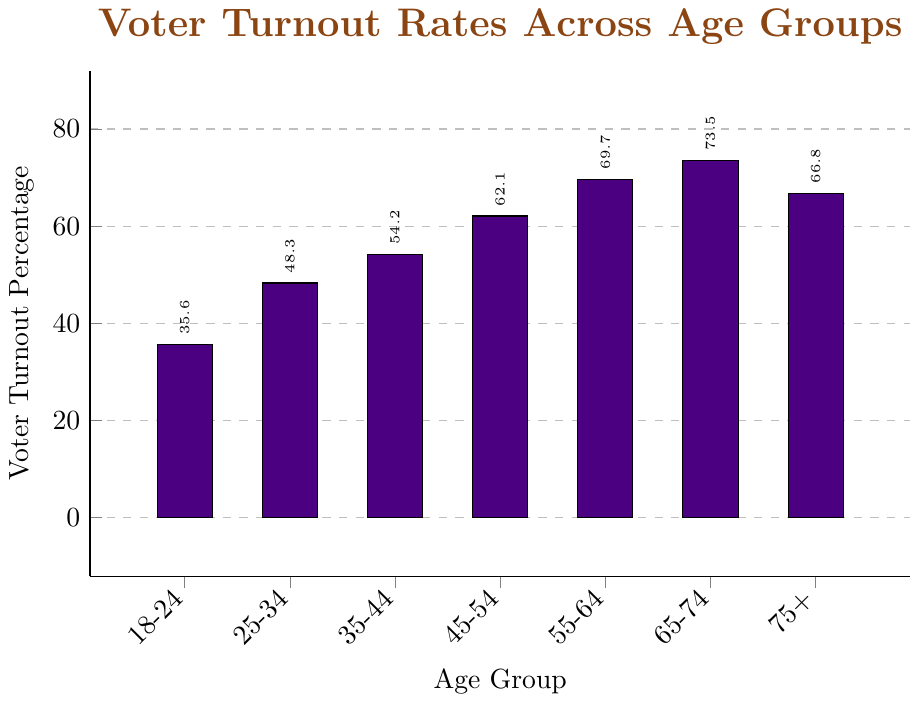What is the voter turnout percentage for the age group 18-24? Locate the bar labeled "18-24" and check the height of the bar, which indicates the voter turnout percentage.
Answer: 35.6% Which age group has the highest voter turnout percentage? Among the bars, the tallest one represents the age group with the highest voter turnout percentage.
Answer: 65-74 Is the voter turnout percentage for the age group 45-54 greater than that for the age group 18-24? Compare the heights of the bars for the age groups "45-54" and "18-24". The bar for "45-54" is taller.
Answer: Yes What is the difference in voter turnout percentage between the age groups 65-74 and 75+? Subtract the voter turnout percentage for "75+" (66.8%) from the voter turnout percentage for "65-74" (73.5%).
Answer: 6.7% Which age group has a voter turnout percentage closest to 50%? Identify the bar with a height closest to 50% among all the age groups.
Answer: 25-34 What is the average voter turnout percentage for the age groups 35-44 and 45-54? Add the voter turnout percentages for "35-44" (54.2%) and "45-54" (62.1%) then divide by 2 to find the average.
Answer: 58.15% How many age groups have a voter turnout percentage above 60%? Count the number of bars with heights exceeding 60%.
Answer: 4 What is the total voter turnout percentage for the age groups 55-64 and 65-74? Add the voter turnout percentages for "55-64" (69.7%) and "65-74" (73.5%).
Answer: 143.2% Is the color used for the bars in the chart blue or purple? Observe the color of the bars to determine if it is blue or purple.
Answer: Purple What is the range of voter turnout percentages across all age groups? Identify the maximum (73.5% for 65-74) and minimum (35.6% for 18-24) voter turnout percentages, then subtract the minimum from the maximum.
Answer: 37.9% 